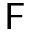<formula> <loc_0><loc_0><loc_500><loc_500>F</formula> 